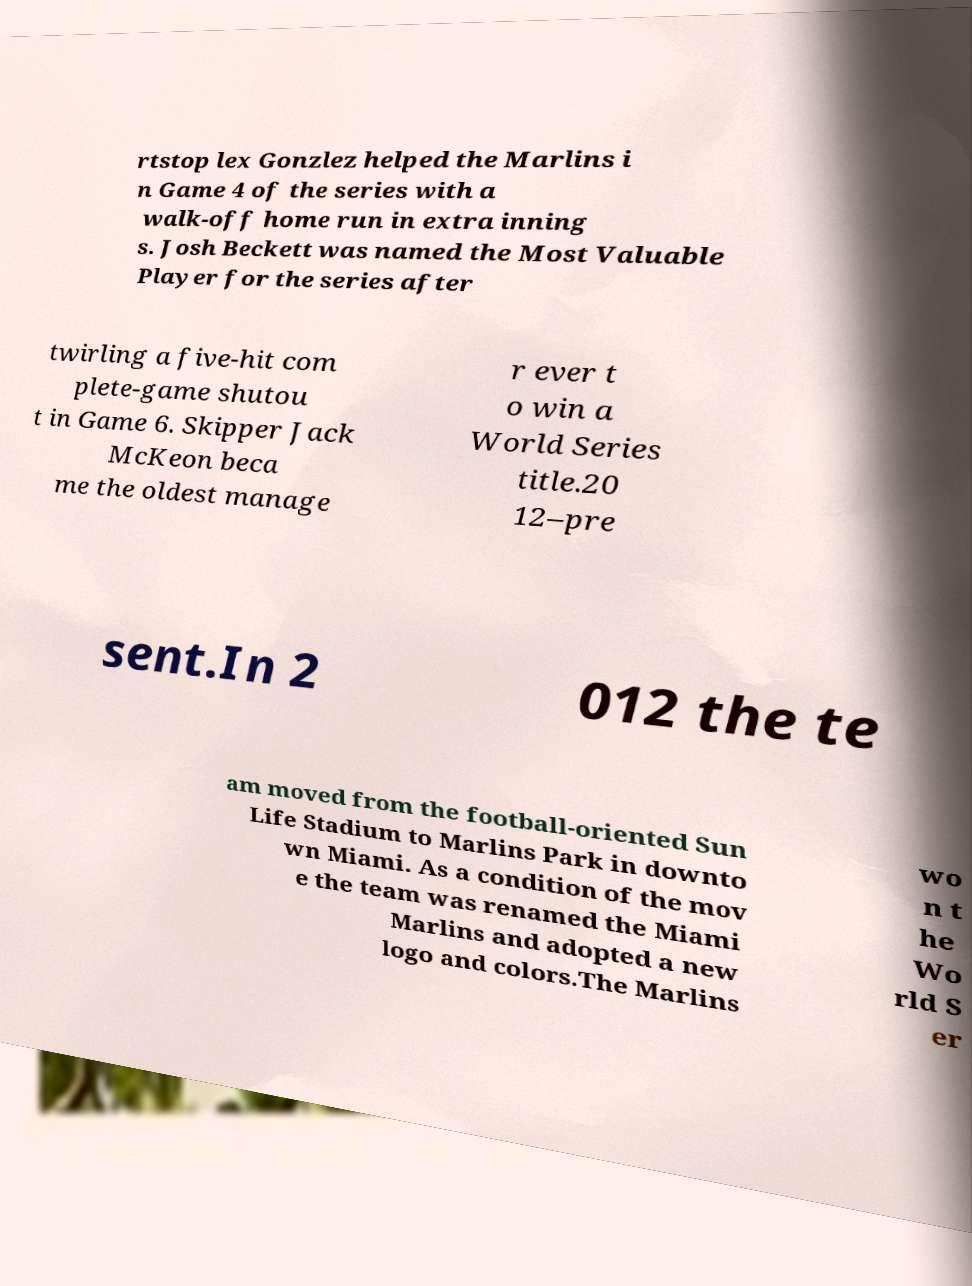Please identify and transcribe the text found in this image. rtstop lex Gonzlez helped the Marlins i n Game 4 of the series with a walk-off home run in extra inning s. Josh Beckett was named the Most Valuable Player for the series after twirling a five-hit com plete-game shutou t in Game 6. Skipper Jack McKeon beca me the oldest manage r ever t o win a World Series title.20 12–pre sent.In 2 012 the te am moved from the football-oriented Sun Life Stadium to Marlins Park in downto wn Miami. As a condition of the mov e the team was renamed the Miami Marlins and adopted a new logo and colors.The Marlins wo n t he Wo rld S er 